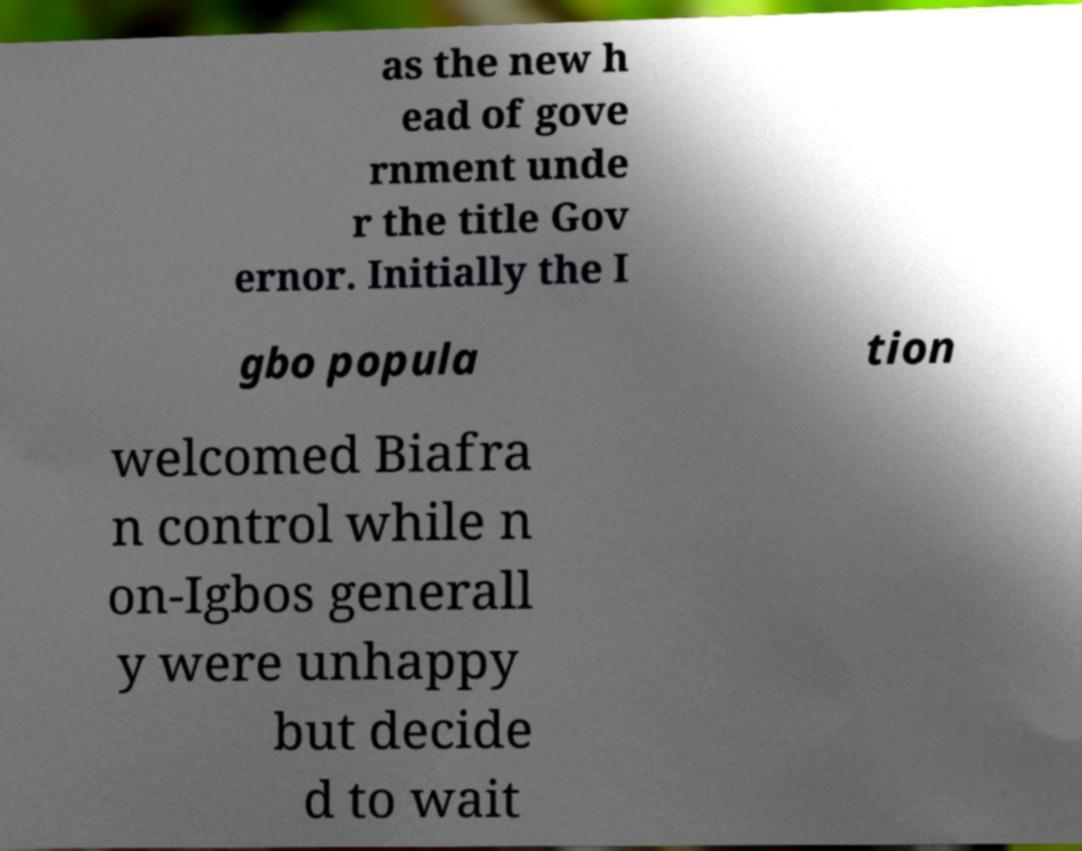Could you assist in decoding the text presented in this image and type it out clearly? as the new h ead of gove rnment unde r the title Gov ernor. Initially the I gbo popula tion welcomed Biafra n control while n on-Igbos generall y were unhappy but decide d to wait 